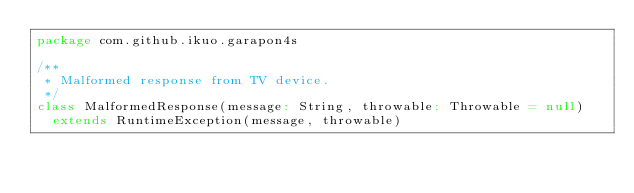Convert code to text. <code><loc_0><loc_0><loc_500><loc_500><_Scala_>package com.github.ikuo.garapon4s

/**
 * Malformed response from TV device.
 */
class MalformedResponse(message: String, throwable: Throwable = null)
  extends RuntimeException(message, throwable)
</code> 